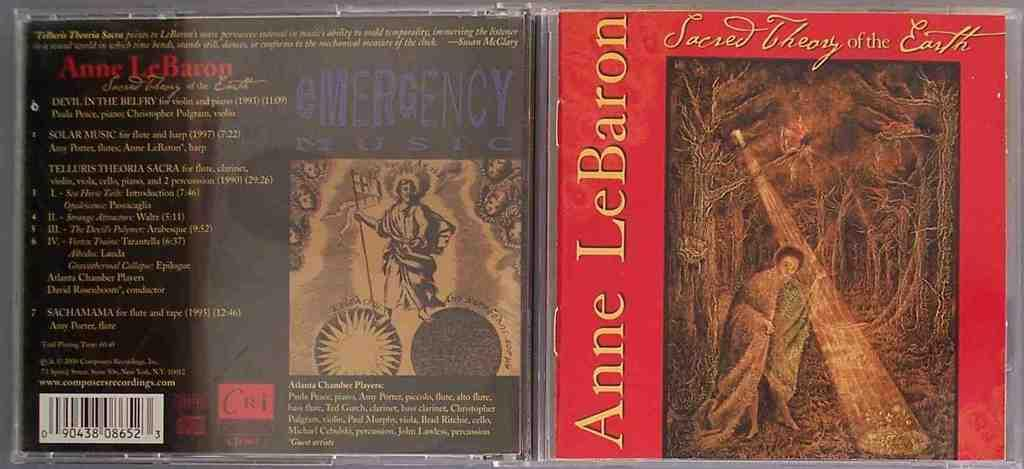Provide a one-sentence caption for the provided image. An Anne LeBaron CD has a red background and a painting of a man. 